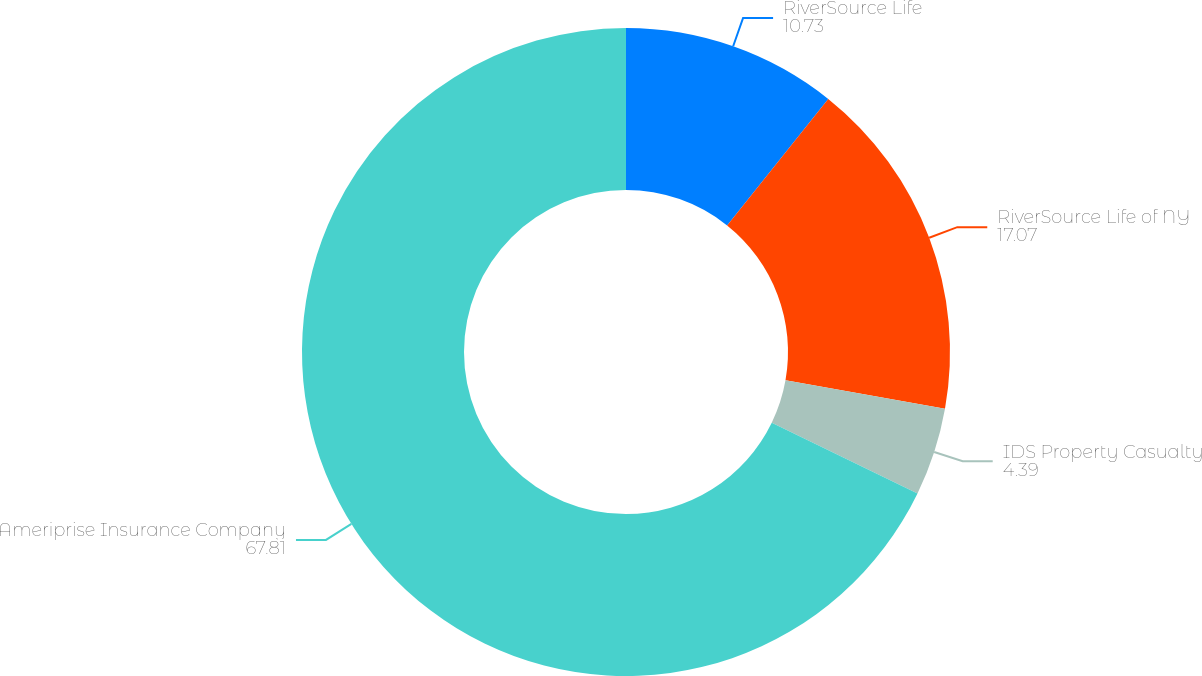Convert chart to OTSL. <chart><loc_0><loc_0><loc_500><loc_500><pie_chart><fcel>RiverSource Life<fcel>RiverSource Life of NY<fcel>IDS Property Casualty<fcel>Ameriprise Insurance Company<nl><fcel>10.73%<fcel>17.07%<fcel>4.39%<fcel>67.81%<nl></chart> 